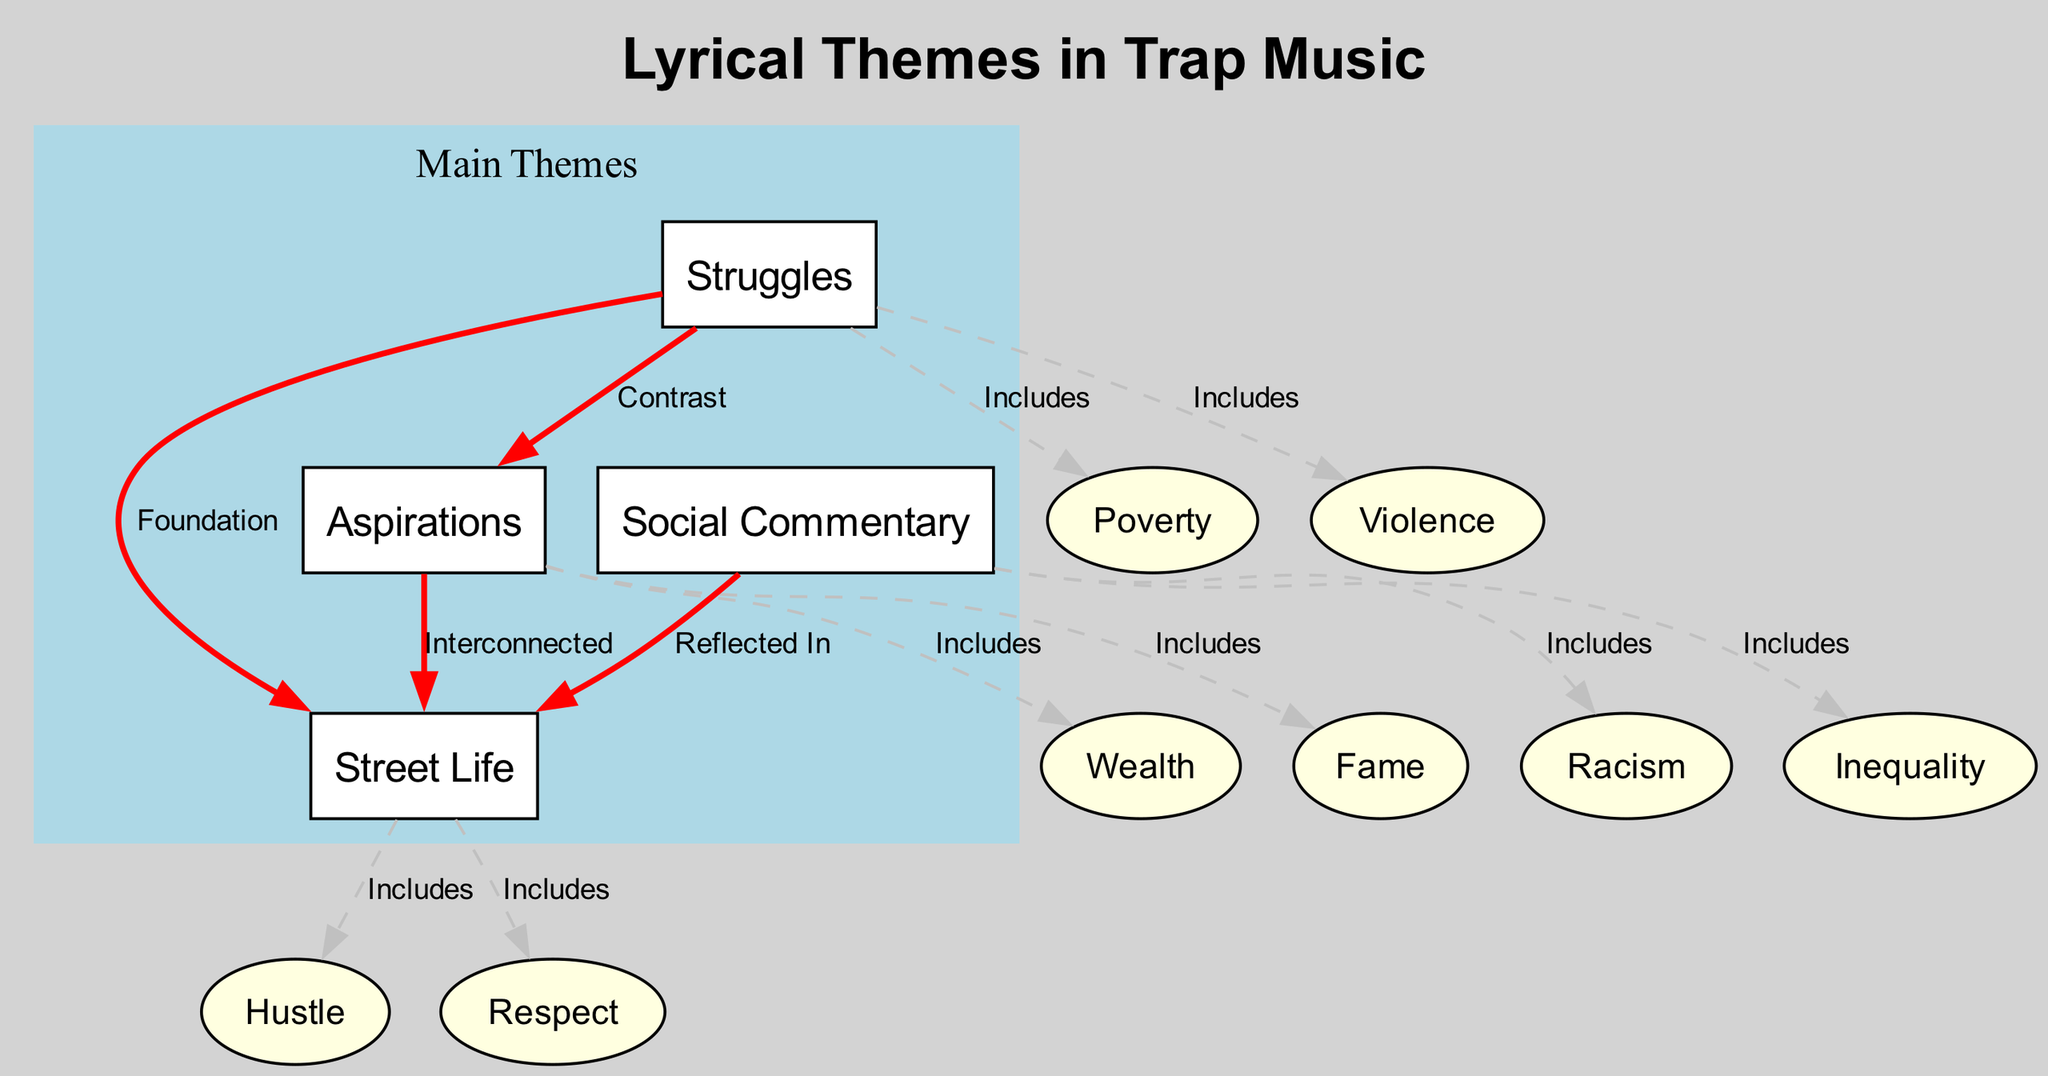What are the main themes in trap music? The diagram identifies four main themes: Struggles, Aspirations, Social Commentary, and Street Life. Each theme is represented as a primary node in the diagram.
Answer: Struggles, Aspirations, Social Commentary, Street Life How many subthemes are under "Struggles"? Under the node "Struggles," there are two subthemes: Poverty and Violence, which both connect to the primary theme through dashed lines indicating inclusion.
Answer: 2 What is the relationship between "Aspirations" and "Wealth"? The connection shows that "Wealth" is a subtheme of "Aspirations," indicated by the dashed line labeled "Includes," signifying that financial success is part of the aspirations in trap music.
Answer: Includes Which themes contrast with each other in the diagram? According to the diagram, "Struggles" and "Aspirations" are contrasted; this is indicated by the solid red line between them labeled "Contrast." This highlights a tension between hardship and dreams.
Answer: Struggles and Aspirations What thematic cluster reflects societal issues? The node "Social Commentary" reflects societal issues, as it includes subthemes like Racism and Inequality, which address social injustices and economic disparities.
Answer: Social Commentary How many edges are labeled "Includes"? The diagram contains five edges labeled as "Includes," connecting various subthemes to their corresponding main themes.
Answer: 5 What is a significant subtheme under "Street Life"? The diagram shows two significant subthemes under "Street Life": Hustle and Respect. These reflect the daily grind and the quest for recognition within street culture.
Answer: Hustle and Respect Which theme is interconnected with both "Aspirations" and "Street Life"? "Street Life" is interconnected with "Aspirations," demonstrating how the experiences and environment of street life influence an individual's dreams and goals.
Answer: Street Life What does the diagram suggest about the relationship between "Social Commentary" and "Street Life"? The diagram indicates that "Social Commentary" is reflected in "Street Life," suggesting that the societal issues are often mirrored in the narratives of street experiences within trap music.
Answer: Reflected In 